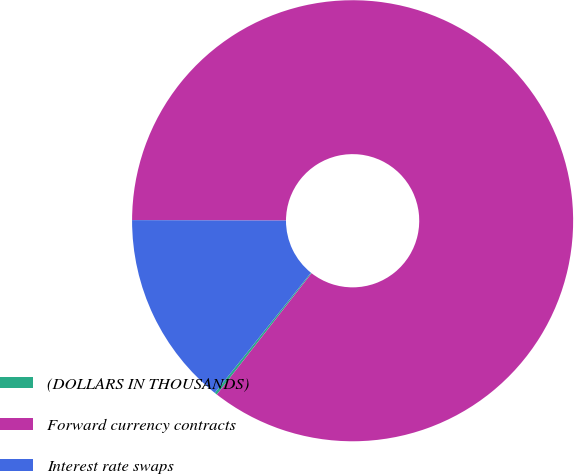<chart> <loc_0><loc_0><loc_500><loc_500><pie_chart><fcel>(DOLLARS IN THOUSANDS)<fcel>Forward currency contracts<fcel>Interest rate swaps<nl><fcel>0.19%<fcel>85.51%<fcel>14.3%<nl></chart> 